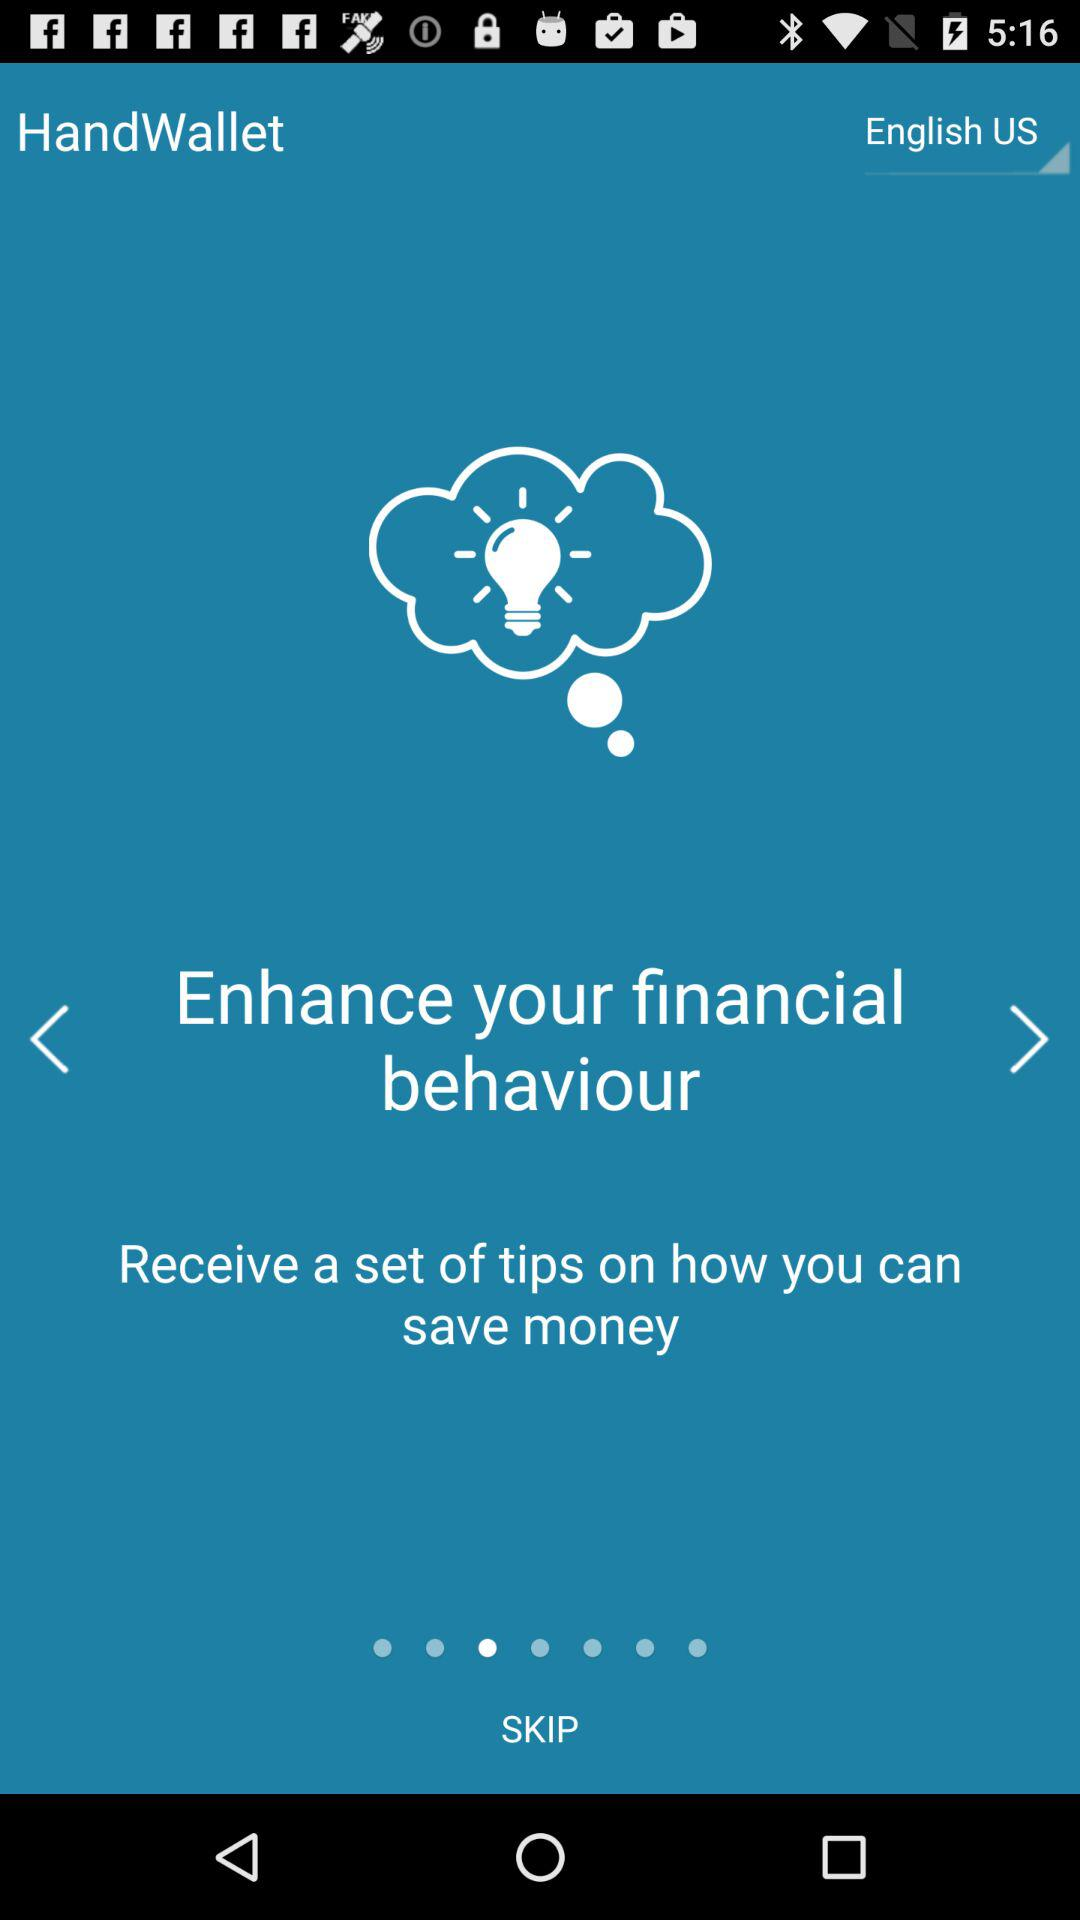What types of tips can be received? The type of tip that can be received is "Enhance your financial behaviour". 